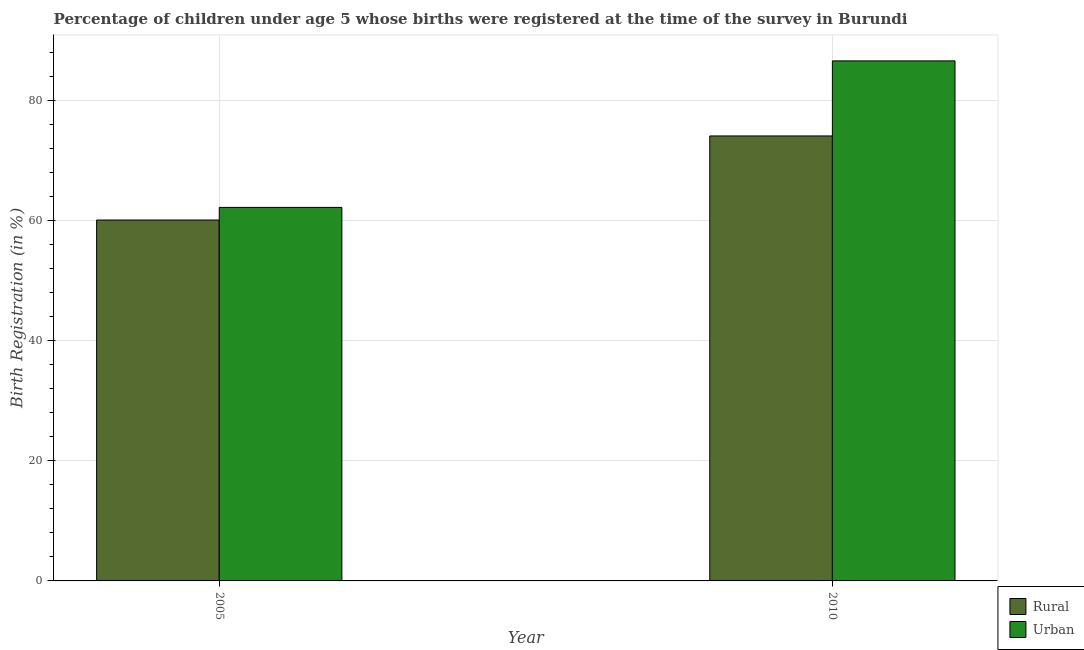How many different coloured bars are there?
Your answer should be very brief. 2. Are the number of bars on each tick of the X-axis equal?
Ensure brevity in your answer.  Yes. How many bars are there on the 2nd tick from the right?
Ensure brevity in your answer.  2. What is the urban birth registration in 2005?
Offer a terse response. 62.2. Across all years, what is the maximum rural birth registration?
Your response must be concise. 74.1. Across all years, what is the minimum urban birth registration?
Ensure brevity in your answer.  62.2. In which year was the urban birth registration maximum?
Your answer should be very brief. 2010. In which year was the rural birth registration minimum?
Your answer should be compact. 2005. What is the total rural birth registration in the graph?
Offer a terse response. 134.2. What is the difference between the urban birth registration in 2005 and that in 2010?
Your answer should be compact. -24.4. What is the difference between the urban birth registration in 2005 and the rural birth registration in 2010?
Provide a short and direct response. -24.4. What is the average urban birth registration per year?
Offer a terse response. 74.4. What is the ratio of the rural birth registration in 2005 to that in 2010?
Give a very brief answer. 0.81. What does the 1st bar from the left in 2005 represents?
Your answer should be compact. Rural. What does the 1st bar from the right in 2005 represents?
Provide a succinct answer. Urban. Does the graph contain any zero values?
Provide a succinct answer. No. Where does the legend appear in the graph?
Provide a short and direct response. Bottom right. How many legend labels are there?
Keep it short and to the point. 2. What is the title of the graph?
Your response must be concise. Percentage of children under age 5 whose births were registered at the time of the survey in Burundi. What is the label or title of the X-axis?
Keep it short and to the point. Year. What is the label or title of the Y-axis?
Keep it short and to the point. Birth Registration (in %). What is the Birth Registration (in %) in Rural in 2005?
Your answer should be very brief. 60.1. What is the Birth Registration (in %) in Urban in 2005?
Provide a succinct answer. 62.2. What is the Birth Registration (in %) in Rural in 2010?
Your response must be concise. 74.1. What is the Birth Registration (in %) of Urban in 2010?
Provide a short and direct response. 86.6. Across all years, what is the maximum Birth Registration (in %) in Rural?
Your answer should be compact. 74.1. Across all years, what is the maximum Birth Registration (in %) in Urban?
Ensure brevity in your answer.  86.6. Across all years, what is the minimum Birth Registration (in %) of Rural?
Give a very brief answer. 60.1. Across all years, what is the minimum Birth Registration (in %) in Urban?
Your answer should be compact. 62.2. What is the total Birth Registration (in %) in Rural in the graph?
Ensure brevity in your answer.  134.2. What is the total Birth Registration (in %) in Urban in the graph?
Ensure brevity in your answer.  148.8. What is the difference between the Birth Registration (in %) of Rural in 2005 and that in 2010?
Make the answer very short. -14. What is the difference between the Birth Registration (in %) in Urban in 2005 and that in 2010?
Keep it short and to the point. -24.4. What is the difference between the Birth Registration (in %) of Rural in 2005 and the Birth Registration (in %) of Urban in 2010?
Ensure brevity in your answer.  -26.5. What is the average Birth Registration (in %) in Rural per year?
Make the answer very short. 67.1. What is the average Birth Registration (in %) in Urban per year?
Keep it short and to the point. 74.4. In the year 2005, what is the difference between the Birth Registration (in %) of Rural and Birth Registration (in %) of Urban?
Make the answer very short. -2.1. What is the ratio of the Birth Registration (in %) of Rural in 2005 to that in 2010?
Offer a very short reply. 0.81. What is the ratio of the Birth Registration (in %) of Urban in 2005 to that in 2010?
Provide a succinct answer. 0.72. What is the difference between the highest and the second highest Birth Registration (in %) of Urban?
Offer a very short reply. 24.4. What is the difference between the highest and the lowest Birth Registration (in %) of Urban?
Offer a terse response. 24.4. 